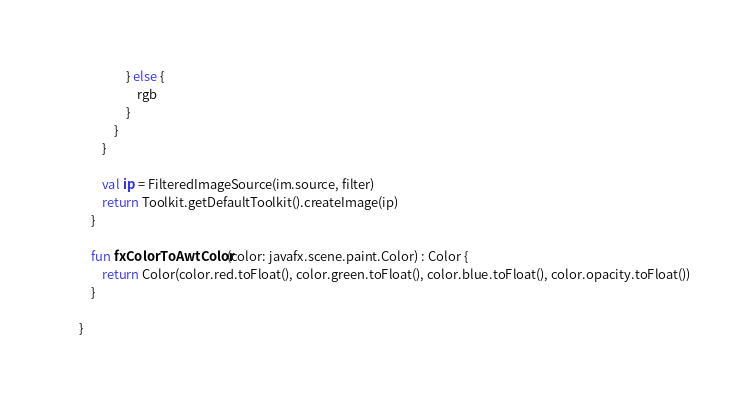<code> <loc_0><loc_0><loc_500><loc_500><_Kotlin_>                } else {
                    rgb
                }
            }
        }

        val ip = FilteredImageSource(im.source, filter)
        return Toolkit.getDefaultToolkit().createImage(ip)
    }

    fun fxColorToAwtColor(color: javafx.scene.paint.Color) : Color {
        return Color(color.red.toFloat(), color.green.toFloat(), color.blue.toFloat(), color.opacity.toFloat())
    }

}</code> 